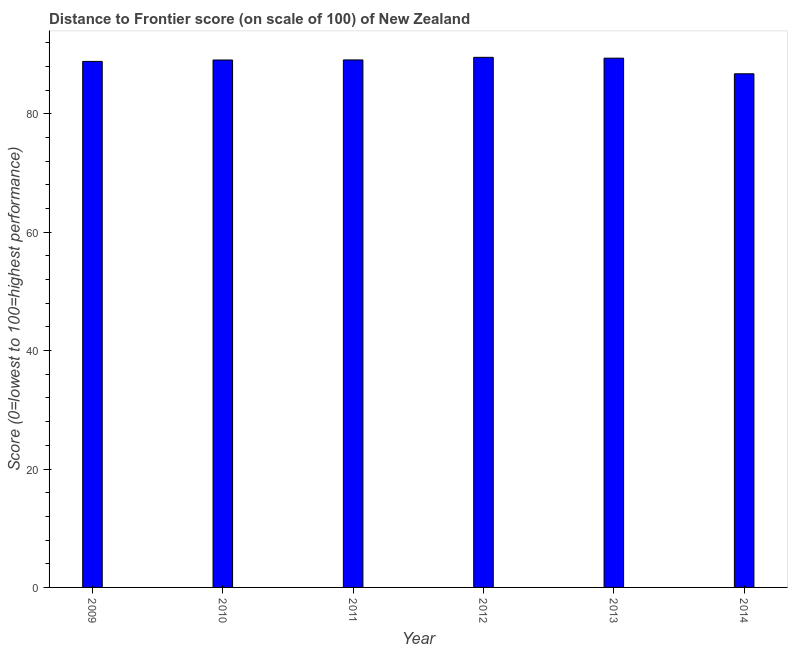Does the graph contain any zero values?
Your answer should be very brief. No. Does the graph contain grids?
Your answer should be compact. No. What is the title of the graph?
Give a very brief answer. Distance to Frontier score (on scale of 100) of New Zealand. What is the label or title of the Y-axis?
Provide a short and direct response. Score (0=lowest to 100=highest performance). What is the distance to frontier score in 2014?
Give a very brief answer. 86.75. Across all years, what is the maximum distance to frontier score?
Provide a succinct answer. 89.53. Across all years, what is the minimum distance to frontier score?
Your response must be concise. 86.75. What is the sum of the distance to frontier score?
Your answer should be very brief. 532.68. What is the difference between the distance to frontier score in 2010 and 2013?
Ensure brevity in your answer.  -0.31. What is the average distance to frontier score per year?
Keep it short and to the point. 88.78. What is the median distance to frontier score?
Give a very brief answer. 89.09. Do a majority of the years between 2014 and 2011 (inclusive) have distance to frontier score greater than 24 ?
Your response must be concise. Yes. What is the difference between the highest and the second highest distance to frontier score?
Ensure brevity in your answer.  0.14. Is the sum of the distance to frontier score in 2009 and 2011 greater than the maximum distance to frontier score across all years?
Make the answer very short. Yes. What is the difference between the highest and the lowest distance to frontier score?
Offer a terse response. 2.78. In how many years, is the distance to frontier score greater than the average distance to frontier score taken over all years?
Provide a succinct answer. 5. How many bars are there?
Your response must be concise. 6. How many years are there in the graph?
Offer a very short reply. 6. What is the difference between two consecutive major ticks on the Y-axis?
Your answer should be very brief. 20. Are the values on the major ticks of Y-axis written in scientific E-notation?
Provide a succinct answer. No. What is the Score (0=lowest to 100=highest performance) in 2009?
Give a very brief answer. 88.84. What is the Score (0=lowest to 100=highest performance) of 2010?
Give a very brief answer. 89.08. What is the Score (0=lowest to 100=highest performance) in 2011?
Ensure brevity in your answer.  89.09. What is the Score (0=lowest to 100=highest performance) of 2012?
Provide a short and direct response. 89.53. What is the Score (0=lowest to 100=highest performance) in 2013?
Keep it short and to the point. 89.39. What is the Score (0=lowest to 100=highest performance) in 2014?
Offer a very short reply. 86.75. What is the difference between the Score (0=lowest to 100=highest performance) in 2009 and 2010?
Offer a very short reply. -0.24. What is the difference between the Score (0=lowest to 100=highest performance) in 2009 and 2011?
Provide a short and direct response. -0.25. What is the difference between the Score (0=lowest to 100=highest performance) in 2009 and 2012?
Offer a very short reply. -0.69. What is the difference between the Score (0=lowest to 100=highest performance) in 2009 and 2013?
Provide a short and direct response. -0.55. What is the difference between the Score (0=lowest to 100=highest performance) in 2009 and 2014?
Provide a succinct answer. 2.09. What is the difference between the Score (0=lowest to 100=highest performance) in 2010 and 2011?
Your answer should be compact. -0.01. What is the difference between the Score (0=lowest to 100=highest performance) in 2010 and 2012?
Provide a short and direct response. -0.45. What is the difference between the Score (0=lowest to 100=highest performance) in 2010 and 2013?
Make the answer very short. -0.31. What is the difference between the Score (0=lowest to 100=highest performance) in 2010 and 2014?
Ensure brevity in your answer.  2.33. What is the difference between the Score (0=lowest to 100=highest performance) in 2011 and 2012?
Your answer should be very brief. -0.44. What is the difference between the Score (0=lowest to 100=highest performance) in 2011 and 2014?
Offer a terse response. 2.34. What is the difference between the Score (0=lowest to 100=highest performance) in 2012 and 2013?
Provide a short and direct response. 0.14. What is the difference between the Score (0=lowest to 100=highest performance) in 2012 and 2014?
Give a very brief answer. 2.78. What is the difference between the Score (0=lowest to 100=highest performance) in 2013 and 2014?
Provide a succinct answer. 2.64. What is the ratio of the Score (0=lowest to 100=highest performance) in 2009 to that in 2010?
Make the answer very short. 1. What is the ratio of the Score (0=lowest to 100=highest performance) in 2009 to that in 2011?
Give a very brief answer. 1. What is the ratio of the Score (0=lowest to 100=highest performance) in 2009 to that in 2012?
Offer a terse response. 0.99. What is the ratio of the Score (0=lowest to 100=highest performance) in 2009 to that in 2013?
Give a very brief answer. 0.99. What is the ratio of the Score (0=lowest to 100=highest performance) in 2009 to that in 2014?
Offer a very short reply. 1.02. What is the ratio of the Score (0=lowest to 100=highest performance) in 2010 to that in 2012?
Provide a short and direct response. 0.99. What is the ratio of the Score (0=lowest to 100=highest performance) in 2010 to that in 2014?
Your answer should be very brief. 1.03. What is the ratio of the Score (0=lowest to 100=highest performance) in 2011 to that in 2012?
Your answer should be compact. 0.99. What is the ratio of the Score (0=lowest to 100=highest performance) in 2012 to that in 2014?
Keep it short and to the point. 1.03. 